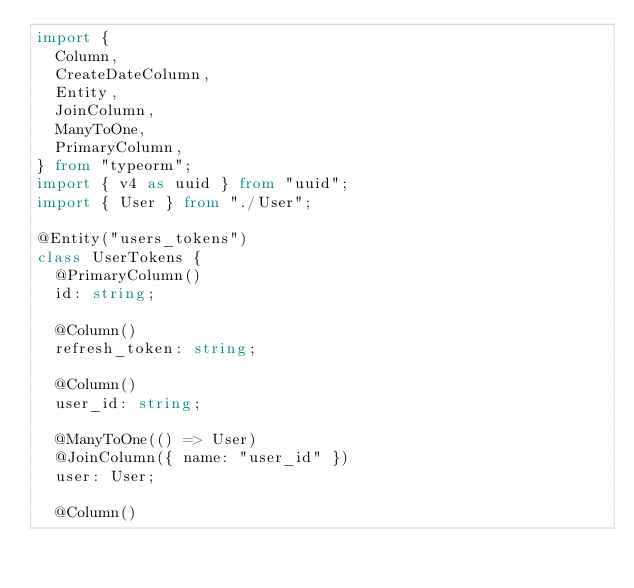Convert code to text. <code><loc_0><loc_0><loc_500><loc_500><_TypeScript_>import {
  Column,
  CreateDateColumn,
  Entity,
  JoinColumn,
  ManyToOne,
  PrimaryColumn,
} from "typeorm";
import { v4 as uuid } from "uuid";
import { User } from "./User";

@Entity("users_tokens")
class UserTokens {
  @PrimaryColumn()
  id: string;

  @Column()
  refresh_token: string;

  @Column()
  user_id: string;

  @ManyToOne(() => User)
  @JoinColumn({ name: "user_id" })
  user: User;

  @Column()</code> 